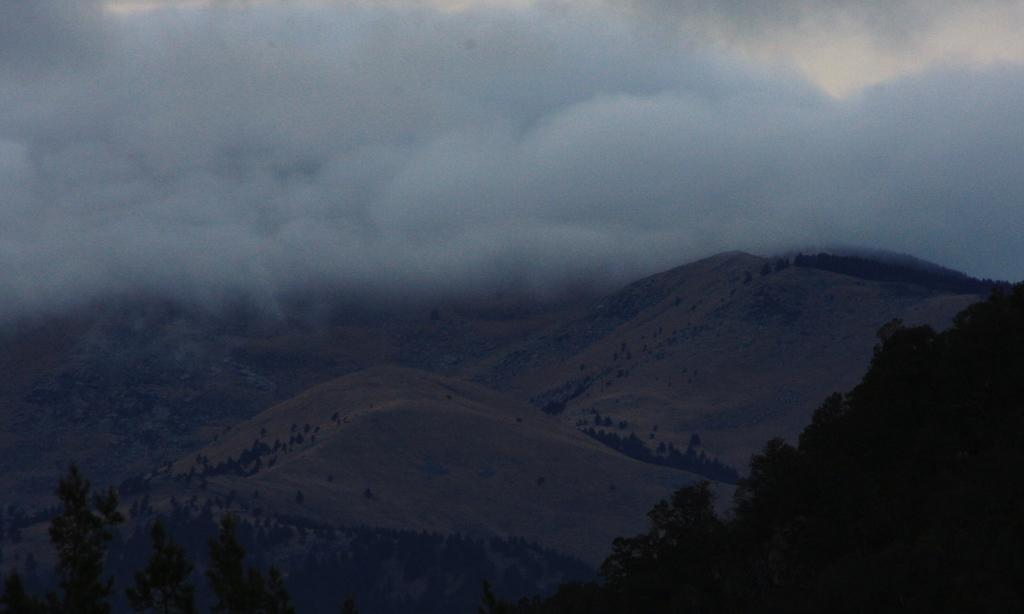What type of vegetation can be seen in the image? There are trees in the image. What geographical feature is present in the image? There is a mountain in the image. What is visible in the sky in the image? The sky is visible in the image. What can be seen in the sky in the image? There are clouds in the sky. Can you see any horns or guns in the image? No, there are no horns or guns present in the image. Is there a calculator visible in the image? No, there is no calculator visible in the image. 